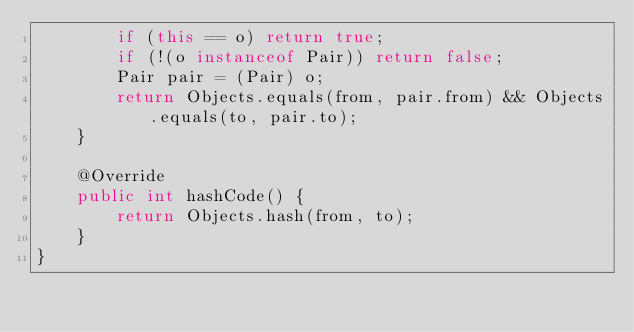Convert code to text. <code><loc_0><loc_0><loc_500><loc_500><_Java_>        if (this == o) return true;
        if (!(o instanceof Pair)) return false;
        Pair pair = (Pair) o;
        return Objects.equals(from, pair.from) && Objects.equals(to, pair.to);
    }

    @Override
    public int hashCode() {
        return Objects.hash(from, to);
    }
}
</code> 